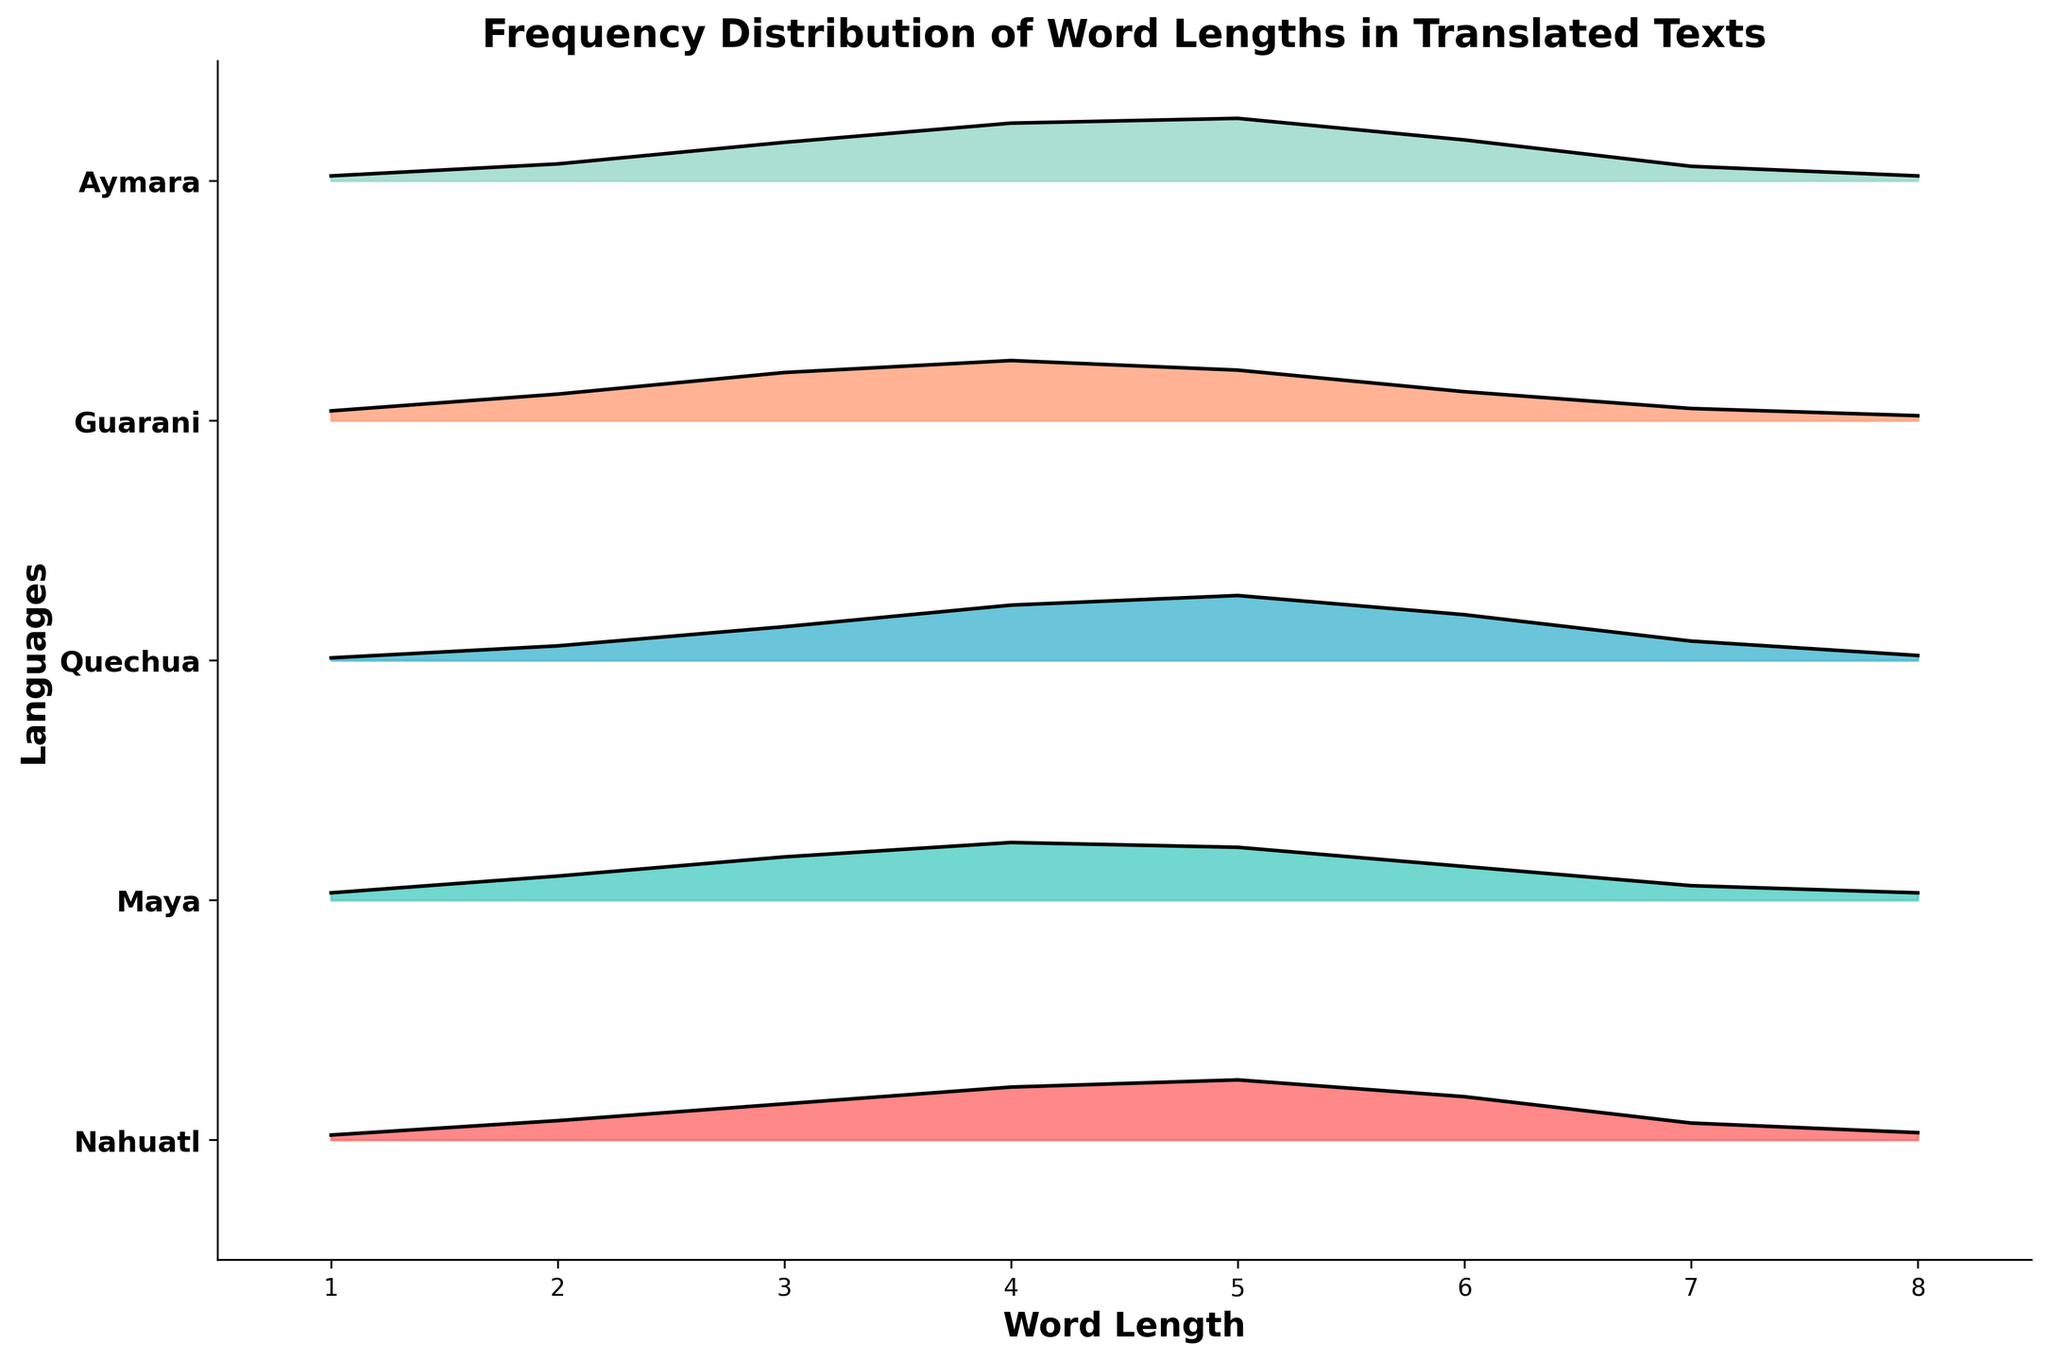What are the titles and labels of the axes? The figure has a title "Frequency Distribution of Word Lengths in Translated Texts". The x-axis is labeled "Word Length" and the y-axis is labeled "Languages".
Answer: The title is "Frequency Distribution of Word Lengths in Translated Texts"; x-axis label is "Word Length"; y-axis label is "Languages" How many different indigenous languages are represented in the plot? The y-axis has labels for each language, showing Nahuatl, Maya, Quechua, Guarani, and Aymara in the plot.
Answer: 5 Which language shows the highest frequency of 5-letter words? By looking at the peak heights at word length 5 for each language, Quechua has the highest peak.
Answer: Quechua Which language has the most uniform distribution of word lengths (i.e., smallest variance in frequencies)? Comparing the peaks' differences for each word length, Maya seems to have the most uniform distribution, with the most similar peak heights.
Answer: Maya How does the frequency of 2-letter words in Guarani compare to that in Aymara? Guarani shows a higher frequency at 2-letter words compared to Aymara.
Answer: Guarani has higher frequency Which two languages have the most similar frequency distributions overall? Nahuatl and Aymara have very similar shapes in their frequency distributions, indicated by their overlapping peak positions and heights for each word length.
Answer: Nahuatl and Aymara What is the most common word length across all languages? By observing which word length has the highest frequency peaks across all languages, 4-letter words appear to be the most consistently highest.
Answer: 4-letter words For Nahuatl, what is the difference in frequency between 4-letter and 7-letter words? For Nahuatl, the frequency is 0.22 for 4-letter words and 0.07 for 7-letter words. The difference is 0.22 - 0.07.
Answer: 0.15 Which language shows the highest frequency for the shortest word length (1-letter words)? Guarani has the peak at the highest position for 1-letter words compared to other languages shown.
Answer: Guarani Considering the frequencies of 3-letter words, rank the languages from highest to lowest. By observing the 3-letter word frequency peaks: Guarani (0.20), Maya (0.18), Aymara (0.16), Nahuatl (0.15), Quechua (0.14).
Answer: Guarani, Maya, Aymara, Nahuatl, Quechua 